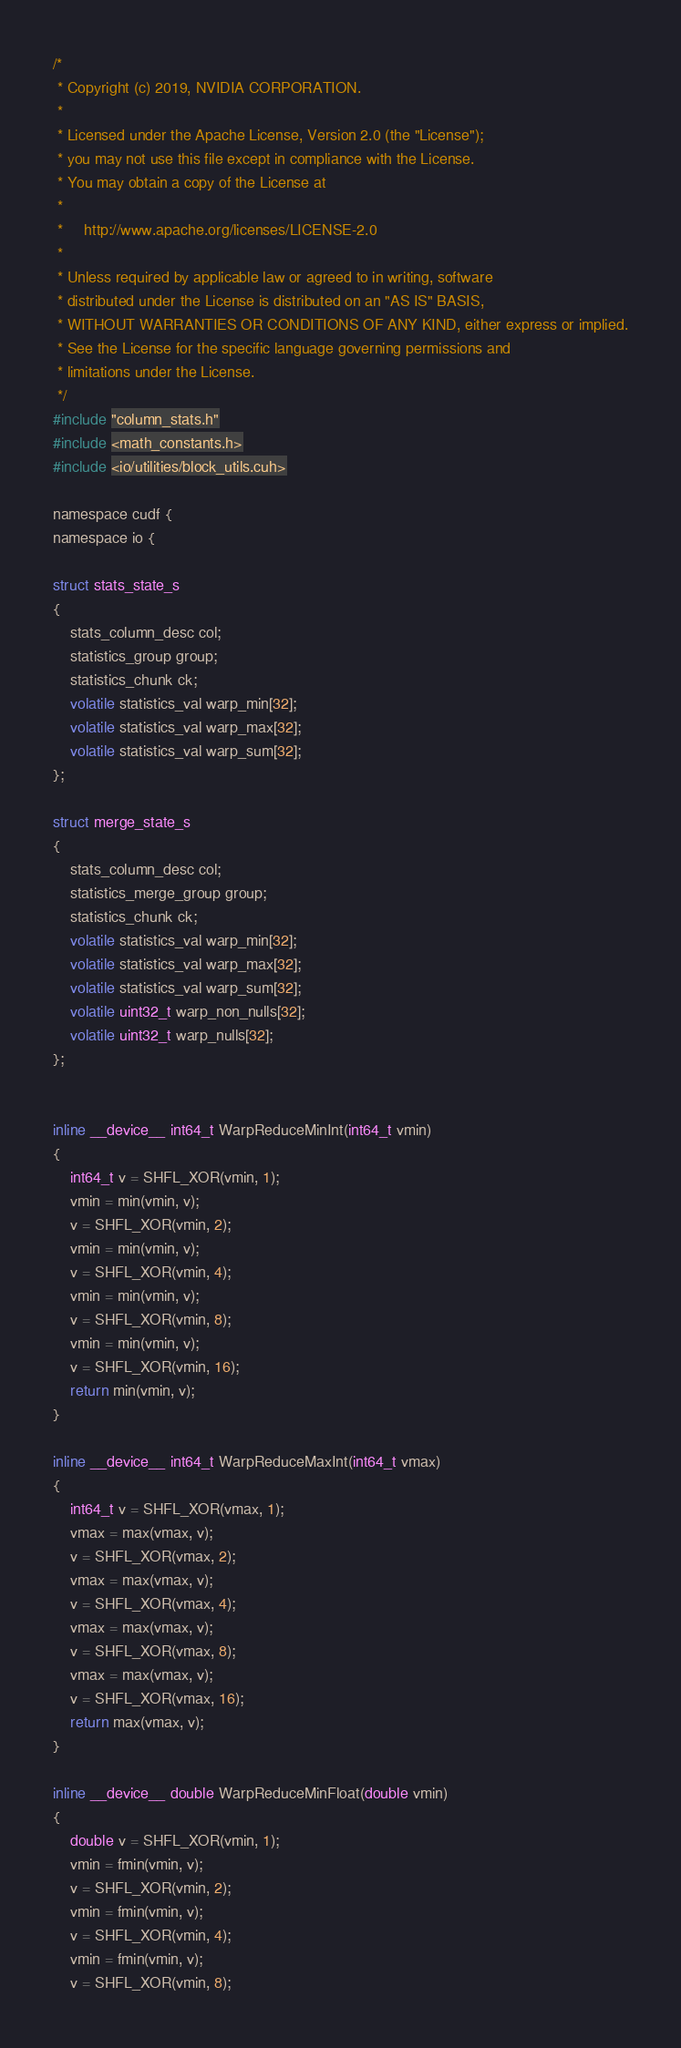Convert code to text. <code><loc_0><loc_0><loc_500><loc_500><_Cuda_>/*
 * Copyright (c) 2019, NVIDIA CORPORATION.
 *
 * Licensed under the Apache License, Version 2.0 (the "License");
 * you may not use this file except in compliance with the License.
 * You may obtain a copy of the License at
 *
 *     http://www.apache.org/licenses/LICENSE-2.0
 *
 * Unless required by applicable law or agreed to in writing, software
 * distributed under the License is distributed on an "AS IS" BASIS,
 * WITHOUT WARRANTIES OR CONDITIONS OF ANY KIND, either express or implied.
 * See the License for the specific language governing permissions and
 * limitations under the License.
 */
#include "column_stats.h"
#include <math_constants.h>
#include <io/utilities/block_utils.cuh>

namespace cudf {
namespace io {

struct stats_state_s
{
    stats_column_desc col;
    statistics_group group;
    statistics_chunk ck;
    volatile statistics_val warp_min[32];
    volatile statistics_val warp_max[32];
    volatile statistics_val warp_sum[32];
};

struct merge_state_s
{
    stats_column_desc col;
    statistics_merge_group group;
    statistics_chunk ck;
    volatile statistics_val warp_min[32];
    volatile statistics_val warp_max[32];
    volatile statistics_val warp_sum[32];
    volatile uint32_t warp_non_nulls[32];
    volatile uint32_t warp_nulls[32];
};


inline __device__ int64_t WarpReduceMinInt(int64_t vmin)
{
    int64_t v = SHFL_XOR(vmin, 1);
    vmin = min(vmin, v);
    v = SHFL_XOR(vmin, 2);
    vmin = min(vmin, v);
    v = SHFL_XOR(vmin, 4);
    vmin = min(vmin, v);
    v = SHFL_XOR(vmin, 8);
    vmin = min(vmin, v);
    v = SHFL_XOR(vmin, 16);
    return min(vmin, v);
}

inline __device__ int64_t WarpReduceMaxInt(int64_t vmax)
{
    int64_t v = SHFL_XOR(vmax, 1);
    vmax = max(vmax, v);
    v = SHFL_XOR(vmax, 2);
    vmax = max(vmax, v);
    v = SHFL_XOR(vmax, 4);
    vmax = max(vmax, v);
    v = SHFL_XOR(vmax, 8);
    vmax = max(vmax, v);
    v = SHFL_XOR(vmax, 16);
    return max(vmax, v);
}

inline __device__ double WarpReduceMinFloat(double vmin)
{
    double v = SHFL_XOR(vmin, 1);
    vmin = fmin(vmin, v);
    v = SHFL_XOR(vmin, 2);
    vmin = fmin(vmin, v);
    v = SHFL_XOR(vmin, 4);
    vmin = fmin(vmin, v);
    v = SHFL_XOR(vmin, 8);</code> 